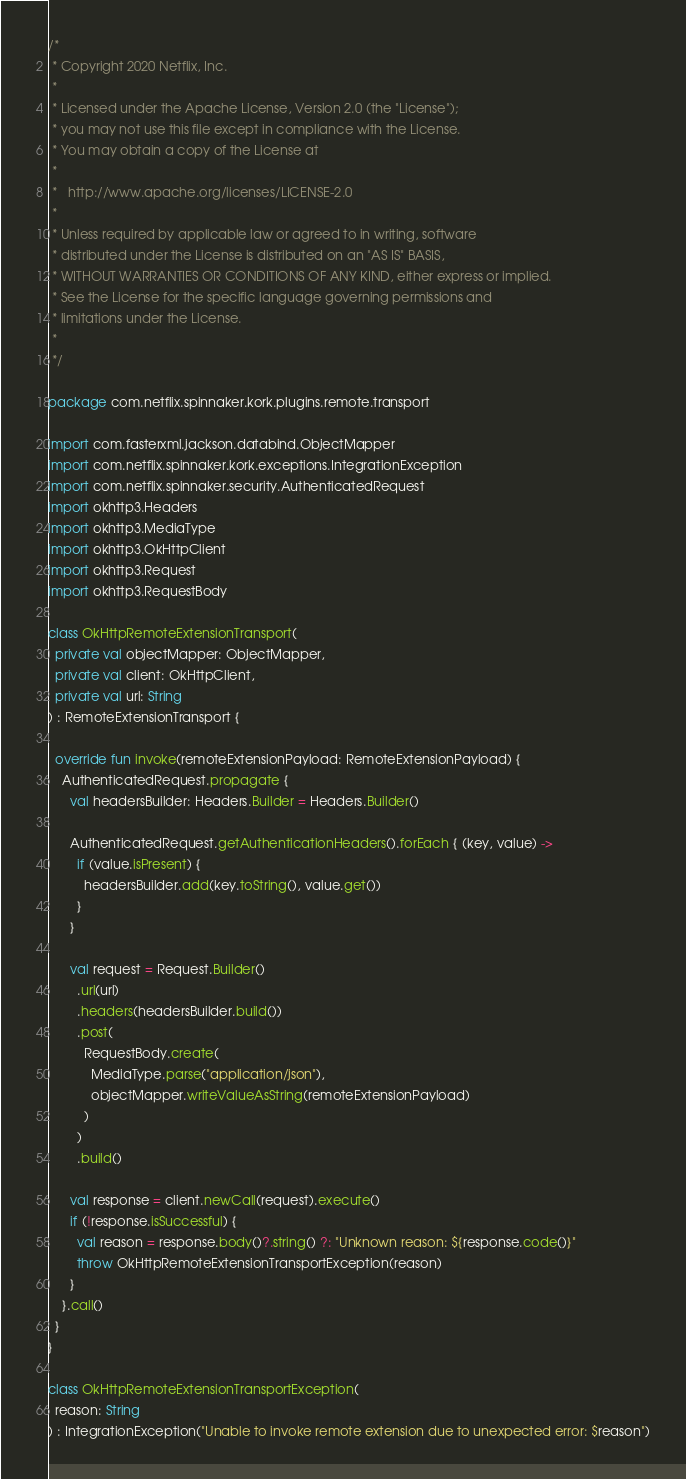<code> <loc_0><loc_0><loc_500><loc_500><_Kotlin_>/*
 * Copyright 2020 Netflix, Inc.
 *
 * Licensed under the Apache License, Version 2.0 (the "License");
 * you may not use this file except in compliance with the License.
 * You may obtain a copy of the License at
 *
 *   http://www.apache.org/licenses/LICENSE-2.0
 *
 * Unless required by applicable law or agreed to in writing, software
 * distributed under the License is distributed on an "AS IS" BASIS,
 * WITHOUT WARRANTIES OR CONDITIONS OF ANY KIND, either express or implied.
 * See the License for the specific language governing permissions and
 * limitations under the License.
 *
 */

package com.netflix.spinnaker.kork.plugins.remote.transport

import com.fasterxml.jackson.databind.ObjectMapper
import com.netflix.spinnaker.kork.exceptions.IntegrationException
import com.netflix.spinnaker.security.AuthenticatedRequest
import okhttp3.Headers
import okhttp3.MediaType
import okhttp3.OkHttpClient
import okhttp3.Request
import okhttp3.RequestBody

class OkHttpRemoteExtensionTransport(
  private val objectMapper: ObjectMapper,
  private val client: OkHttpClient,
  private val url: String
) : RemoteExtensionTransport {

  override fun invoke(remoteExtensionPayload: RemoteExtensionPayload) {
    AuthenticatedRequest.propagate {
      val headersBuilder: Headers.Builder = Headers.Builder()

      AuthenticatedRequest.getAuthenticationHeaders().forEach { (key, value) ->
        if (value.isPresent) {
          headersBuilder.add(key.toString(), value.get())
        }
      }

      val request = Request.Builder()
        .url(url)
        .headers(headersBuilder.build())
        .post(
          RequestBody.create(
            MediaType.parse("application/json"),
            objectMapper.writeValueAsString(remoteExtensionPayload)
          )
        )
        .build()

      val response = client.newCall(request).execute()
      if (!response.isSuccessful) {
        val reason = response.body()?.string() ?: "Unknown reason: ${response.code()}"
        throw OkHttpRemoteExtensionTransportException(reason)
      }
    }.call()
  }
}

class OkHttpRemoteExtensionTransportException(
  reason: String
) : IntegrationException("Unable to invoke remote extension due to unexpected error: $reason")
</code> 